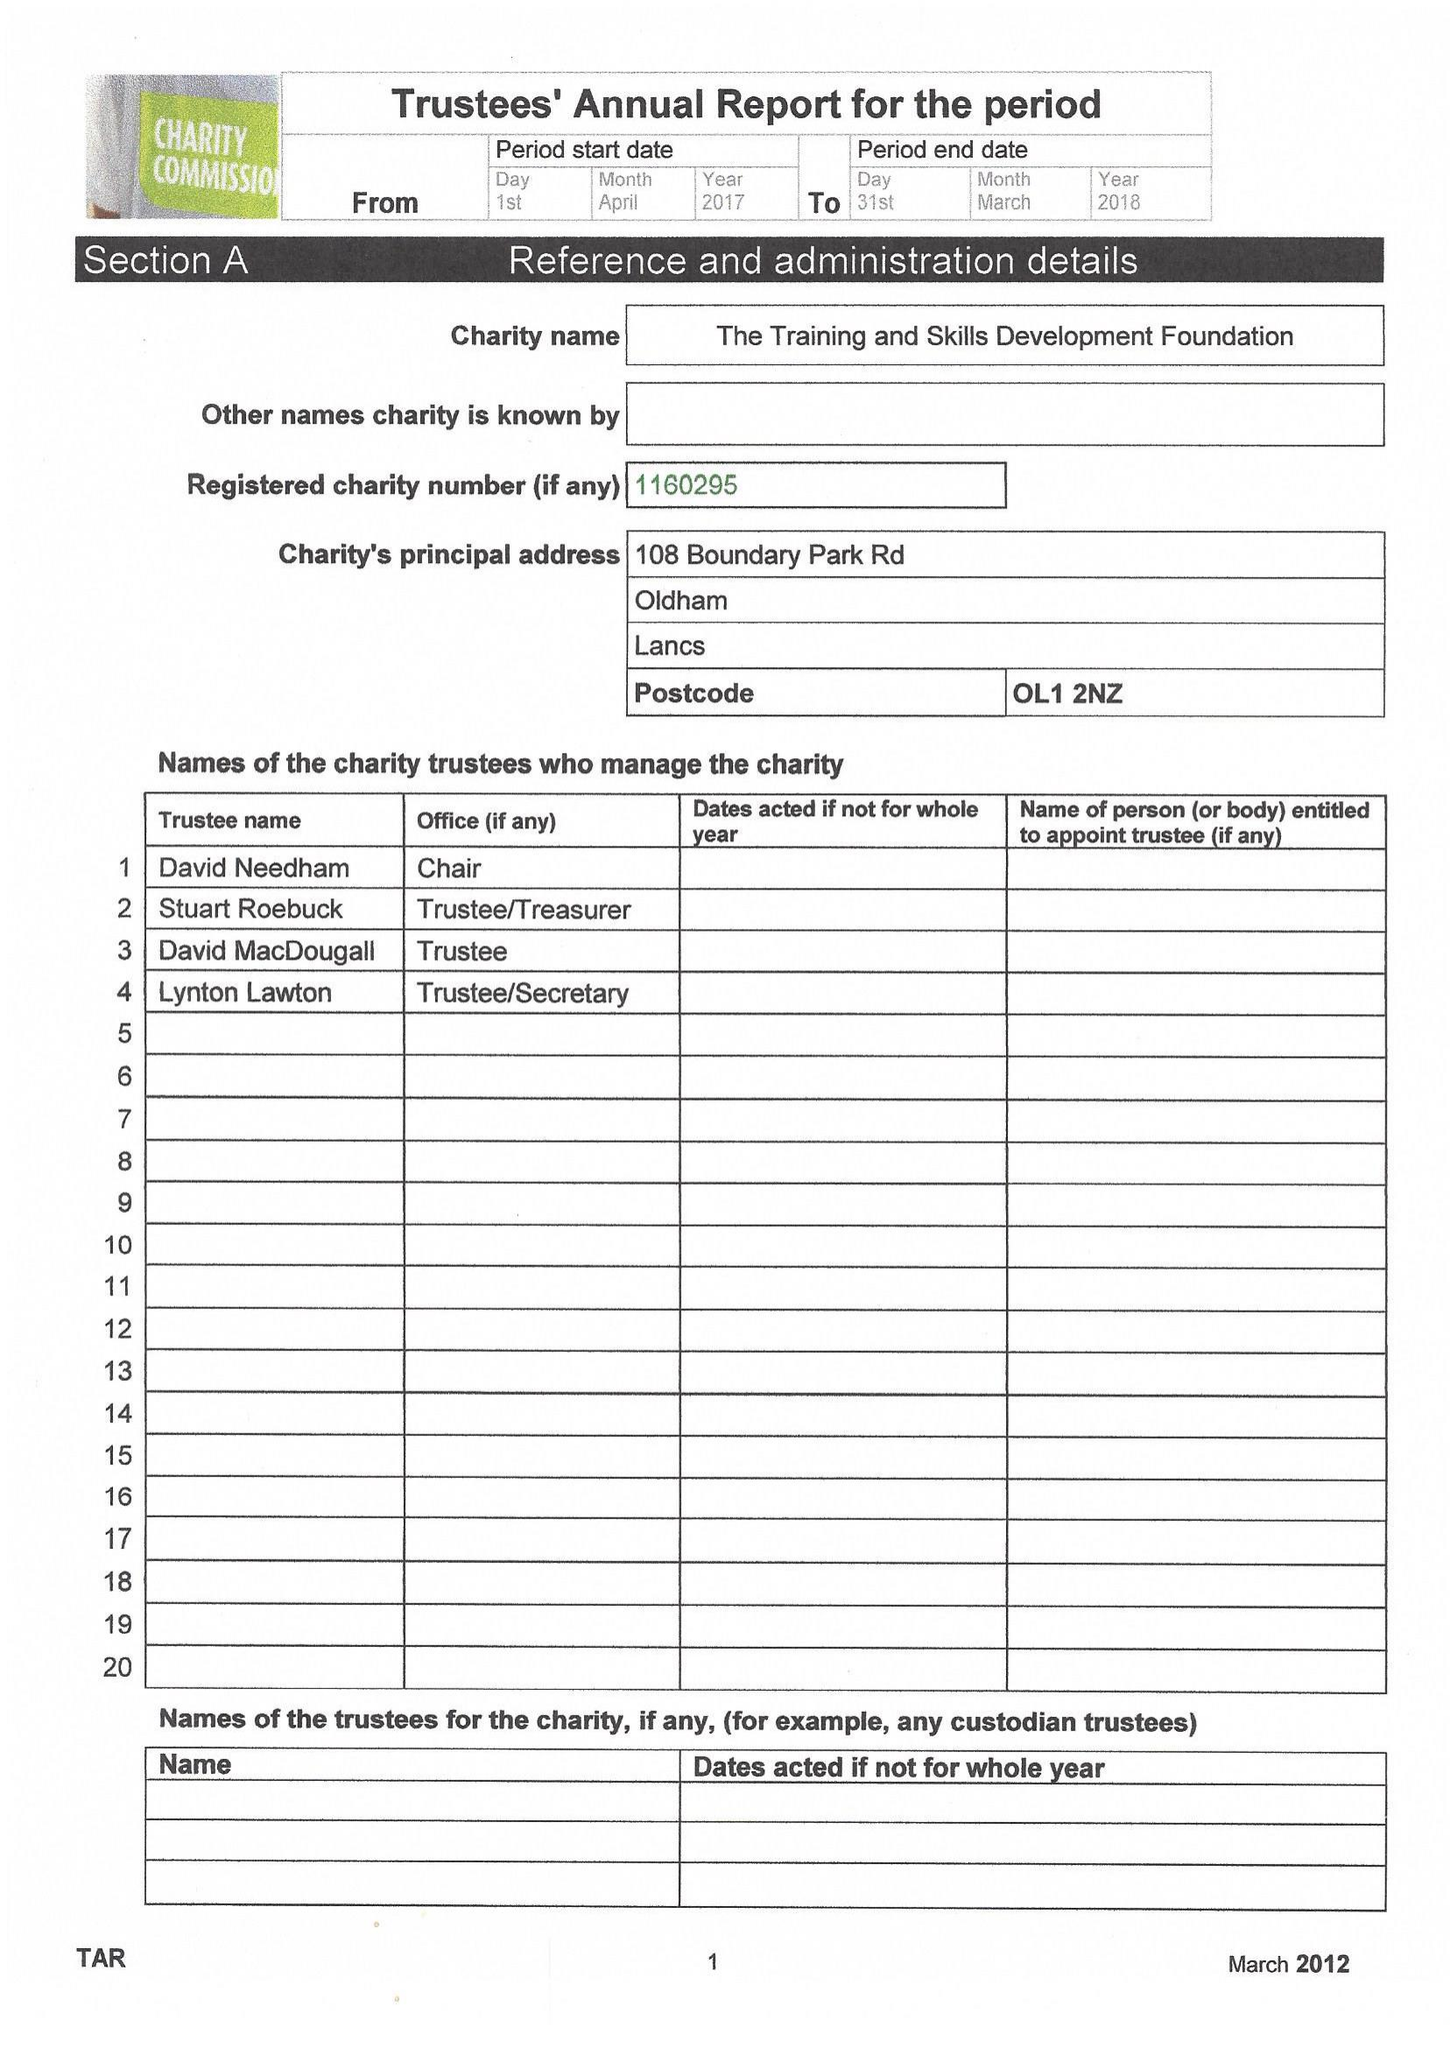What is the value for the report_date?
Answer the question using a single word or phrase. 2018-03-31 